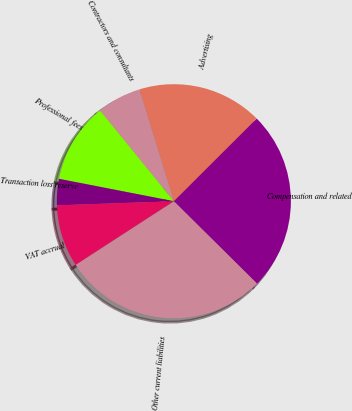Convert chart. <chart><loc_0><loc_0><loc_500><loc_500><pie_chart><fcel>Compensation and related<fcel>Advertising<fcel>Contractors and consultants<fcel>Professional fees<fcel>Transaction loss reserve<fcel>VAT accrual<fcel>Other current liabilities<nl><fcel>24.91%<fcel>17.28%<fcel>6.11%<fcel>11.07%<fcel>3.63%<fcel>8.59%<fcel>28.43%<nl></chart> 